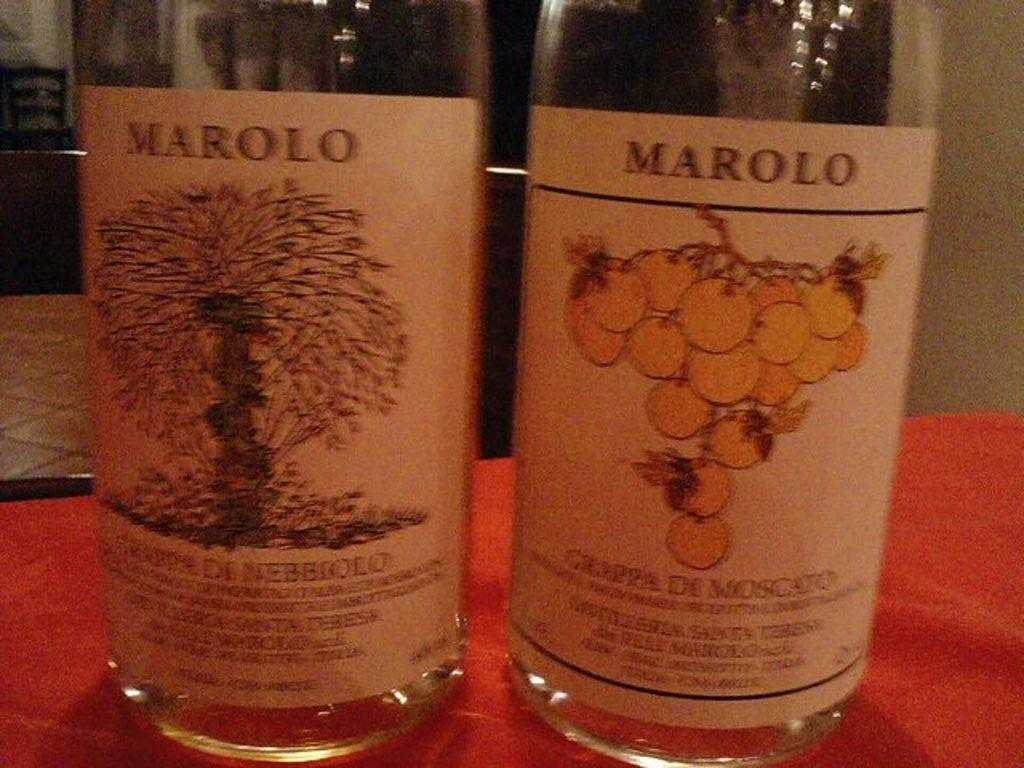<image>
Give a short and clear explanation of the subsequent image. Two bottles with the brand name Marolo are shown next to each other. 